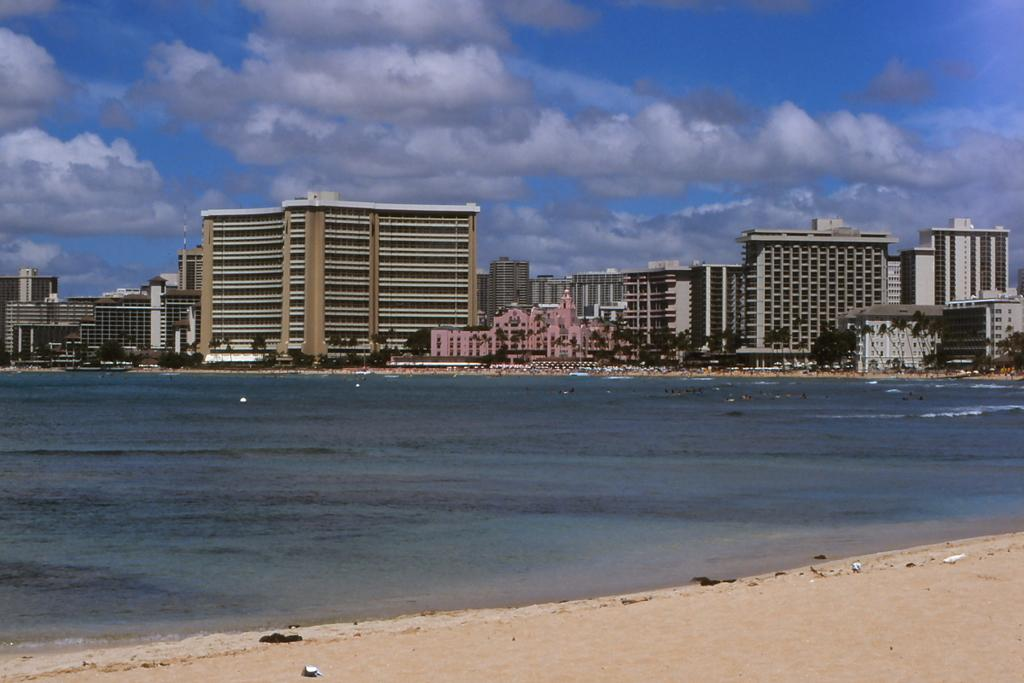What is the primary element in the image? The image contains water. What can be seen in the background of the image? There are buildings, trees, and the sky visible in the background of the image. How do the clouds in the sky appear? The clouds in the sky appear heavy. What type of transport can be seen flying in the image? There is no transport visible in the image; it only contains water, buildings, trees, and the sky. 